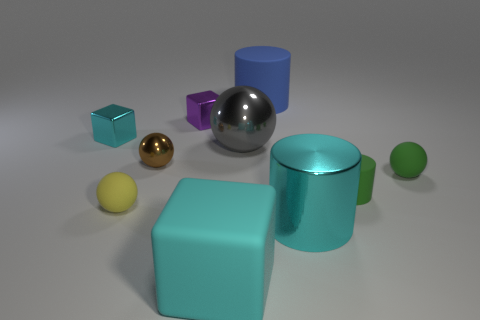Subtract all cyan cylinders. How many cylinders are left? 2 Subtract all gray balls. How many cyan cubes are left? 2 Subtract all brown balls. How many balls are left? 3 Subtract 2 spheres. How many spheres are left? 2 Subtract all spheres. How many objects are left? 6 Subtract all big spheres. Subtract all cyan objects. How many objects are left? 6 Add 9 brown objects. How many brown objects are left? 10 Add 4 purple cylinders. How many purple cylinders exist? 4 Subtract 0 blue blocks. How many objects are left? 10 Subtract all brown cylinders. Subtract all red balls. How many cylinders are left? 3 